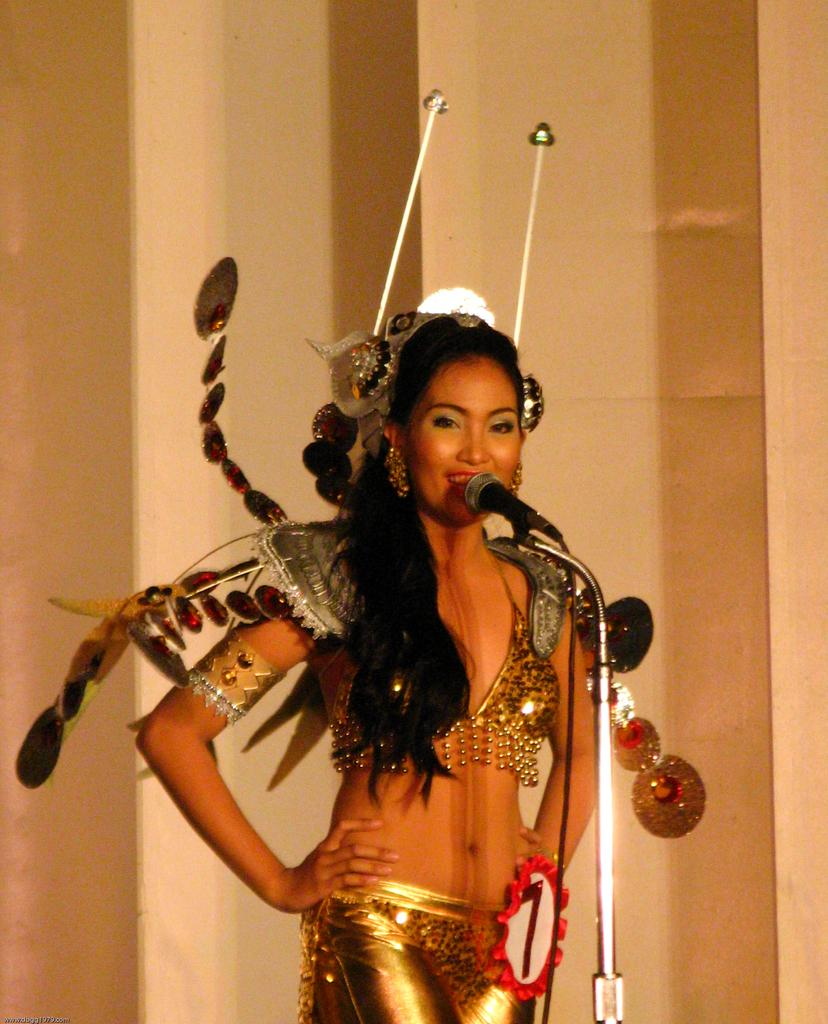Where was the image taken? The image is taken indoors. What can be seen in the background of the image? There is a wall in the background of the image. Who is the main subject in the image? A woman is standing in the middle of the image. What is the woman's facial expression? The woman has a smiling face. What is the woman doing in the image? The woman is talking. What object is present in the image that might be related to the woman's activity? There is a mic present in the image. Can you tell me what type of crime is being committed in the image? There is no indication of any crime being committed in the image. What kind of animals can be seen at the zoo in the image? There is no zoo or animals present in the image. 